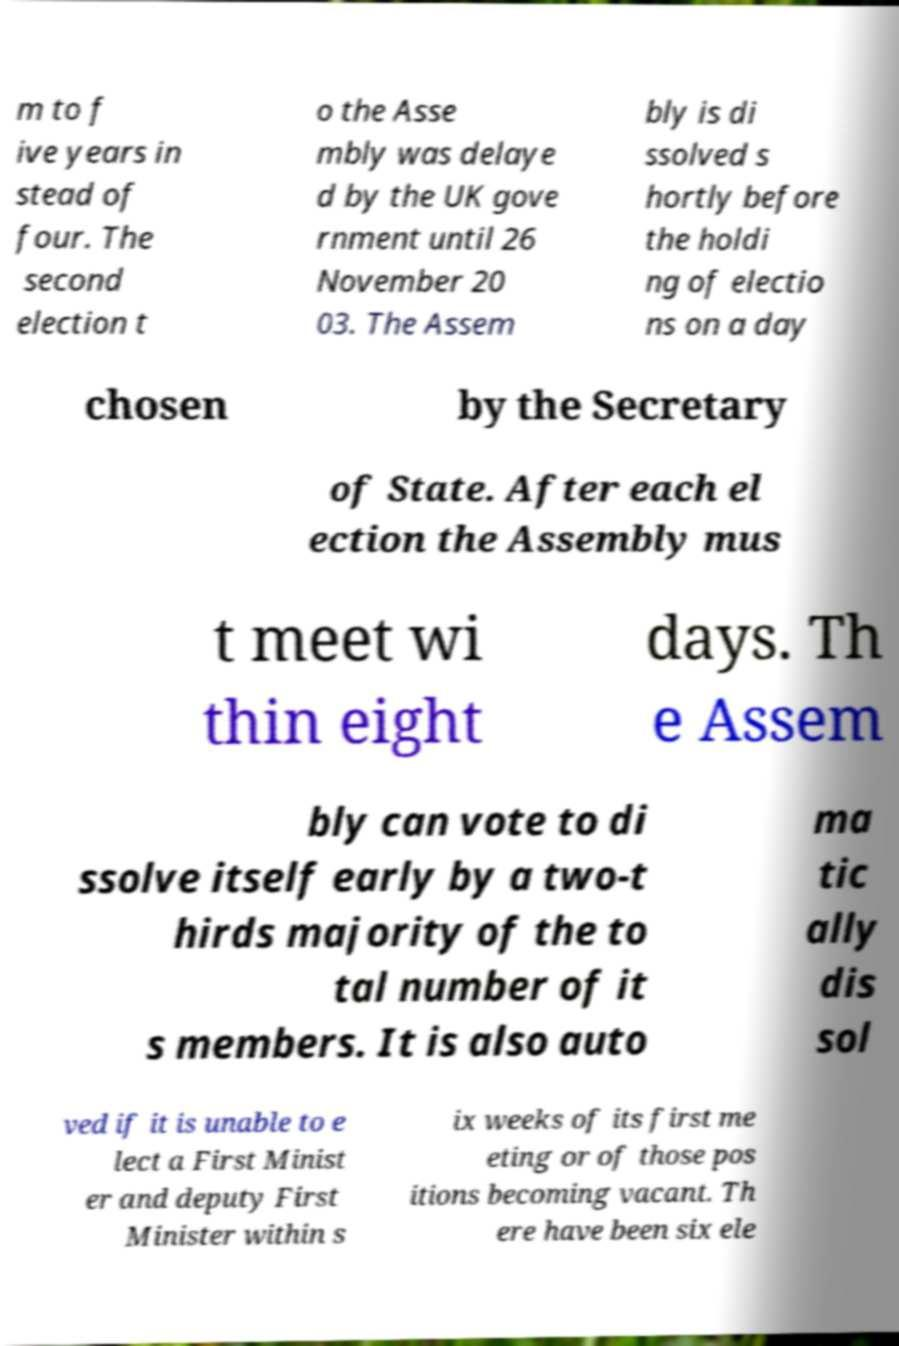What messages or text are displayed in this image? I need them in a readable, typed format. m to f ive years in stead of four. The second election t o the Asse mbly was delaye d by the UK gove rnment until 26 November 20 03. The Assem bly is di ssolved s hortly before the holdi ng of electio ns on a day chosen by the Secretary of State. After each el ection the Assembly mus t meet wi thin eight days. Th e Assem bly can vote to di ssolve itself early by a two-t hirds majority of the to tal number of it s members. It is also auto ma tic ally dis sol ved if it is unable to e lect a First Minist er and deputy First Minister within s ix weeks of its first me eting or of those pos itions becoming vacant. Th ere have been six ele 